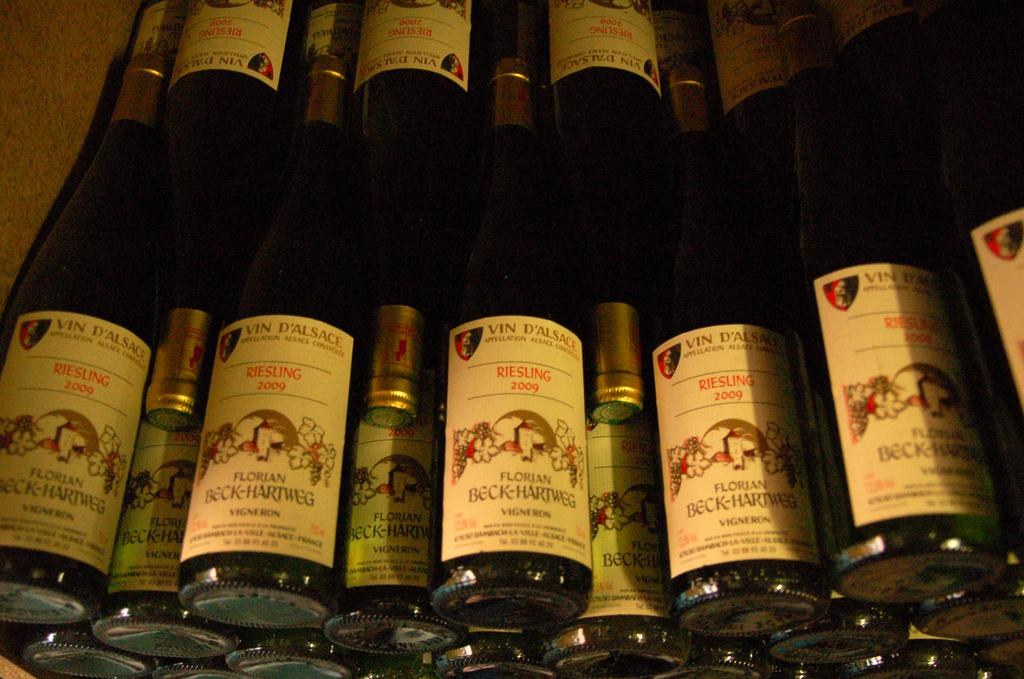<image>
Present a compact description of the photo's key features. A number of bottles of wine, some of which have Riesling on the label. 